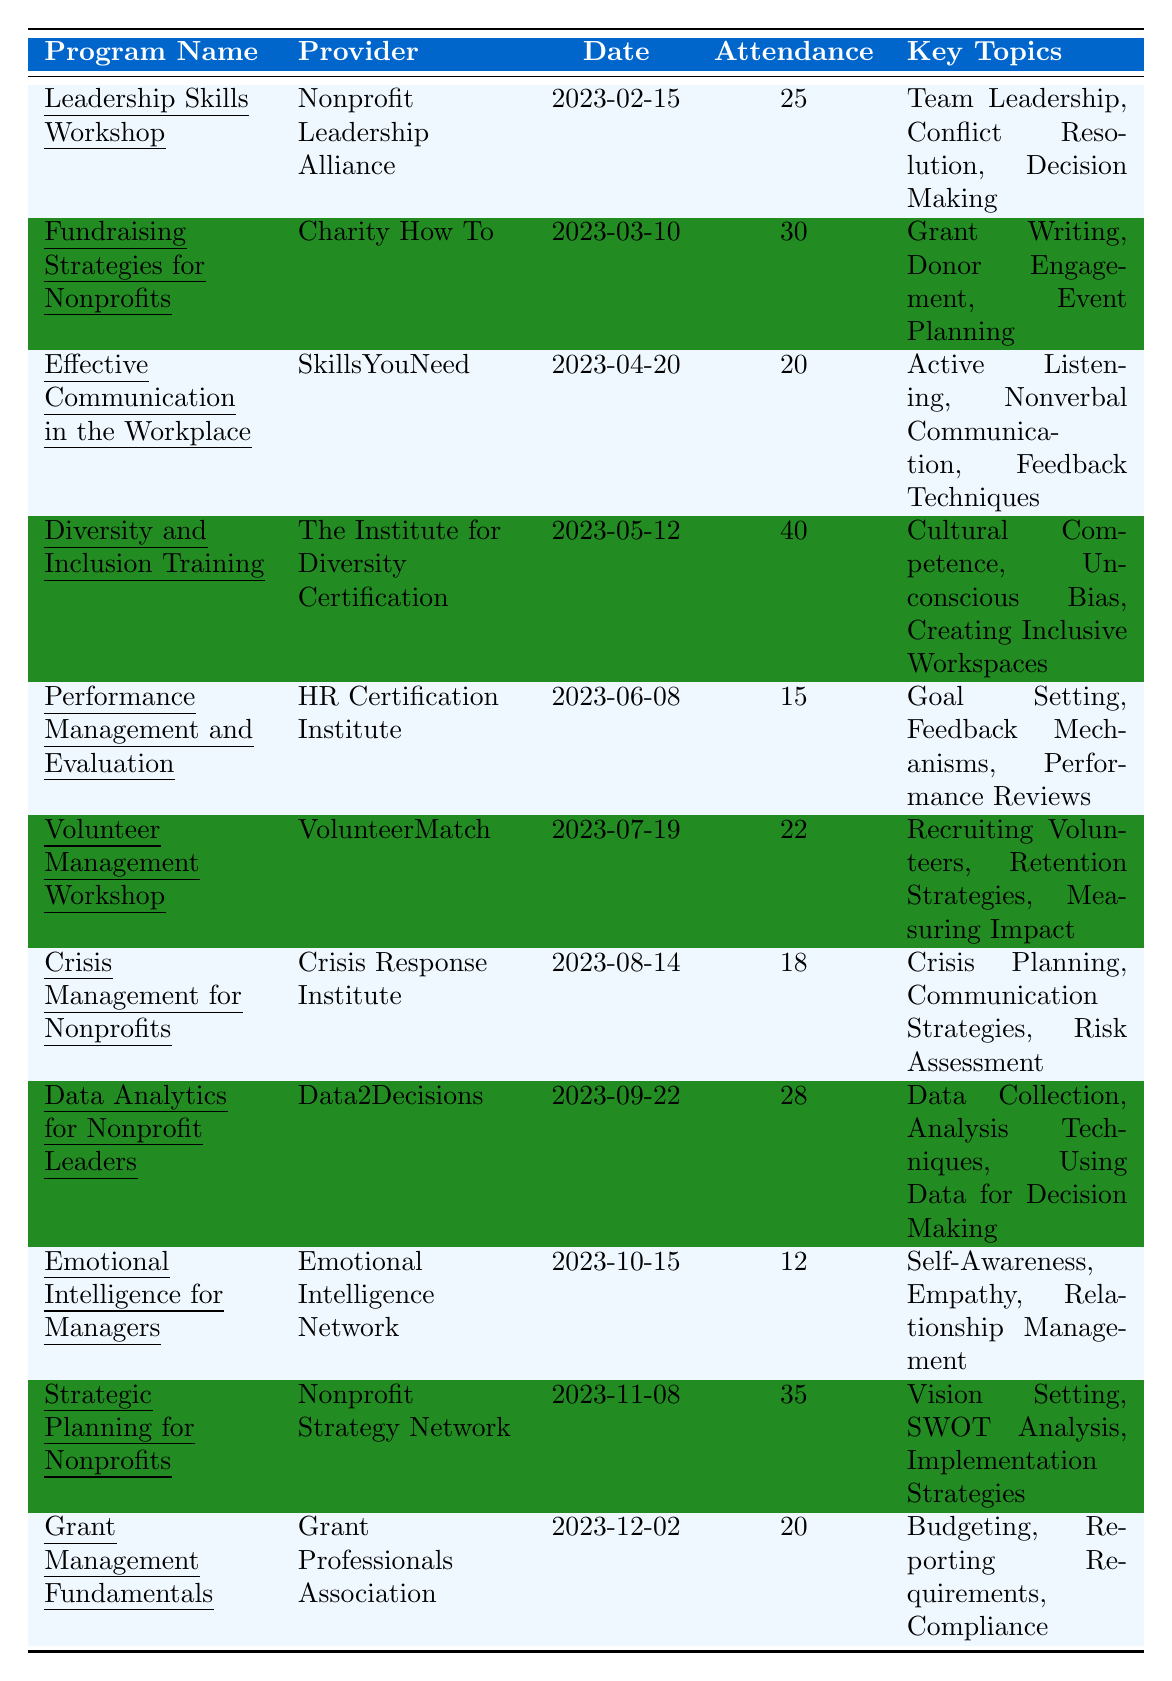What is the total attendance for all training programs? To find the total attendance, I will sum the attendance figures from each program: 25 + 30 + 20 + 40 + 15 + 22 + 18 + 28 + 12 + 35 + 20 = 300.
Answer: 300 Which training program had the highest attendance? By looking at the attendance numbers, the program with the highest attendance is "Diversity and Inclusion Training" with 40 attendees.
Answer: Diversity and Inclusion Training How many programs had an attendance of 20 or more? I will count the programs with attendance data of 20 or more, which are: Leadership Skills Workshop (25), Fundraising Strategies for Nonprofits (30), Diversity and Inclusion Training (40), Volunteer Management Workshop (22), Data Analytics for Nonprofit Leaders (28), Strategic Planning for Nonprofits (35), and Grant Management Fundamentals (20). This totals 7 programs.
Answer: 7 What is the average attendance of all the training programs? The total attendance is 300 from the previous question, and there are 11 programs. Therefore, the average attendance is 300 divided by 11, which equals approximately 27.27.
Answer: 27.27 Did any programs take place on the same date? I will check the dates for each training program and find none are repeated since all provided dates are unique.
Answer: No What percentage of programs were conducted for 1 day? Of the 11 programs, 6 were conducted for 1 day. To find the percentage, I calculate (6/11) * 100, which equals approximately 54.55%.
Answer: 54.55% How many programs focused on communication skills? The programs that focused on communication skills are "Effective Communication in the Workplace" and "Emotional Intelligence for Managers." This gives a total of 2 programs.
Answer: 2 Which provider conducted a program on crisis management? The program "Crisis Management for Nonprofits" was conducted by the provider "Crisis Response Institute."
Answer: Crisis Response Institute List the key topics covered in the "Fundraising Strategies for Nonprofits" program. The key topics for this program include Grant Writing, Donor Engagement, and Event Planning, which are directly listed in the training details.
Answer: Grant Writing, Donor Engagement, Event Planning What is the difference in attendance between the program with the least attendance and the program with the most attendance? The least attendance is 12 (Emotional Intelligence for Managers), and the highest attendance is 40 (Diversity and Inclusion Training). The difference is 40 - 12 = 28.
Answer: 28 